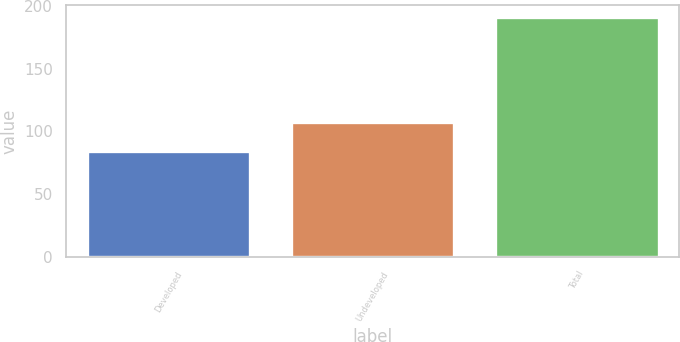Convert chart. <chart><loc_0><loc_0><loc_500><loc_500><bar_chart><fcel>Developed<fcel>Undeveloped<fcel>Total<nl><fcel>84<fcel>107<fcel>191<nl></chart> 